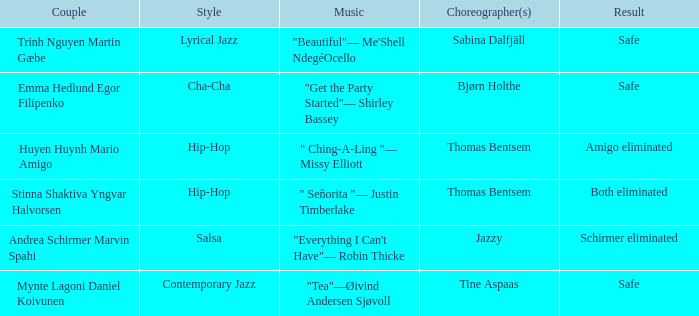What is the result of choreographer bjørn holthe? Safe. 